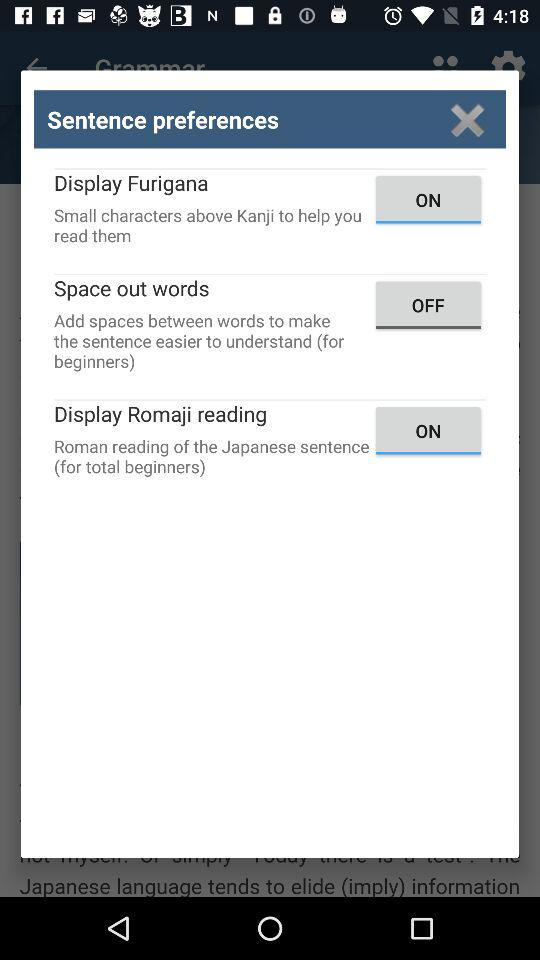What is the version of this application?
When the provided information is insufficient, respond with <no answer>. <no answer> 